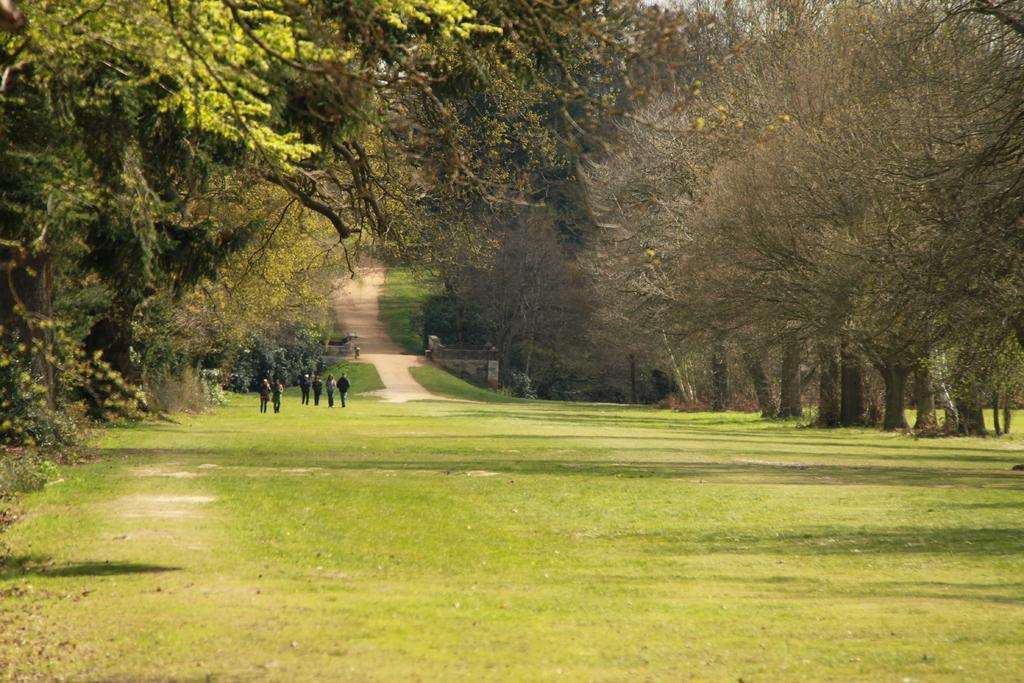Describe this image in one or two sentences. Here in this picture we can see the ground is fully covered with grass and we can also see plants and trees covered all over there and in the far we can see number of people standing and walking on the ground. 